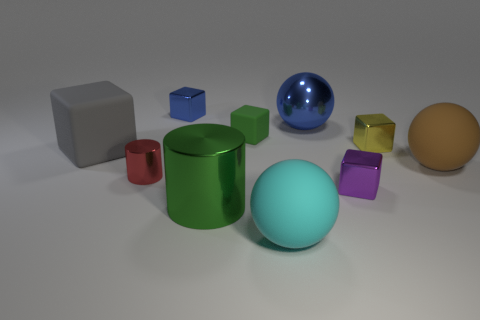Subtract 3 blocks. How many blocks are left? 2 Subtract all brown matte balls. How many balls are left? 2 Subtract all green blocks. How many blocks are left? 4 Subtract all green blocks. Subtract all yellow spheres. How many blocks are left? 4 Subtract all balls. How many objects are left? 7 Subtract 0 green balls. How many objects are left? 10 Subtract all rubber things. Subtract all large gray rubber things. How many objects are left? 5 Add 6 blue shiny blocks. How many blue shiny blocks are left? 7 Add 3 green matte objects. How many green matte objects exist? 4 